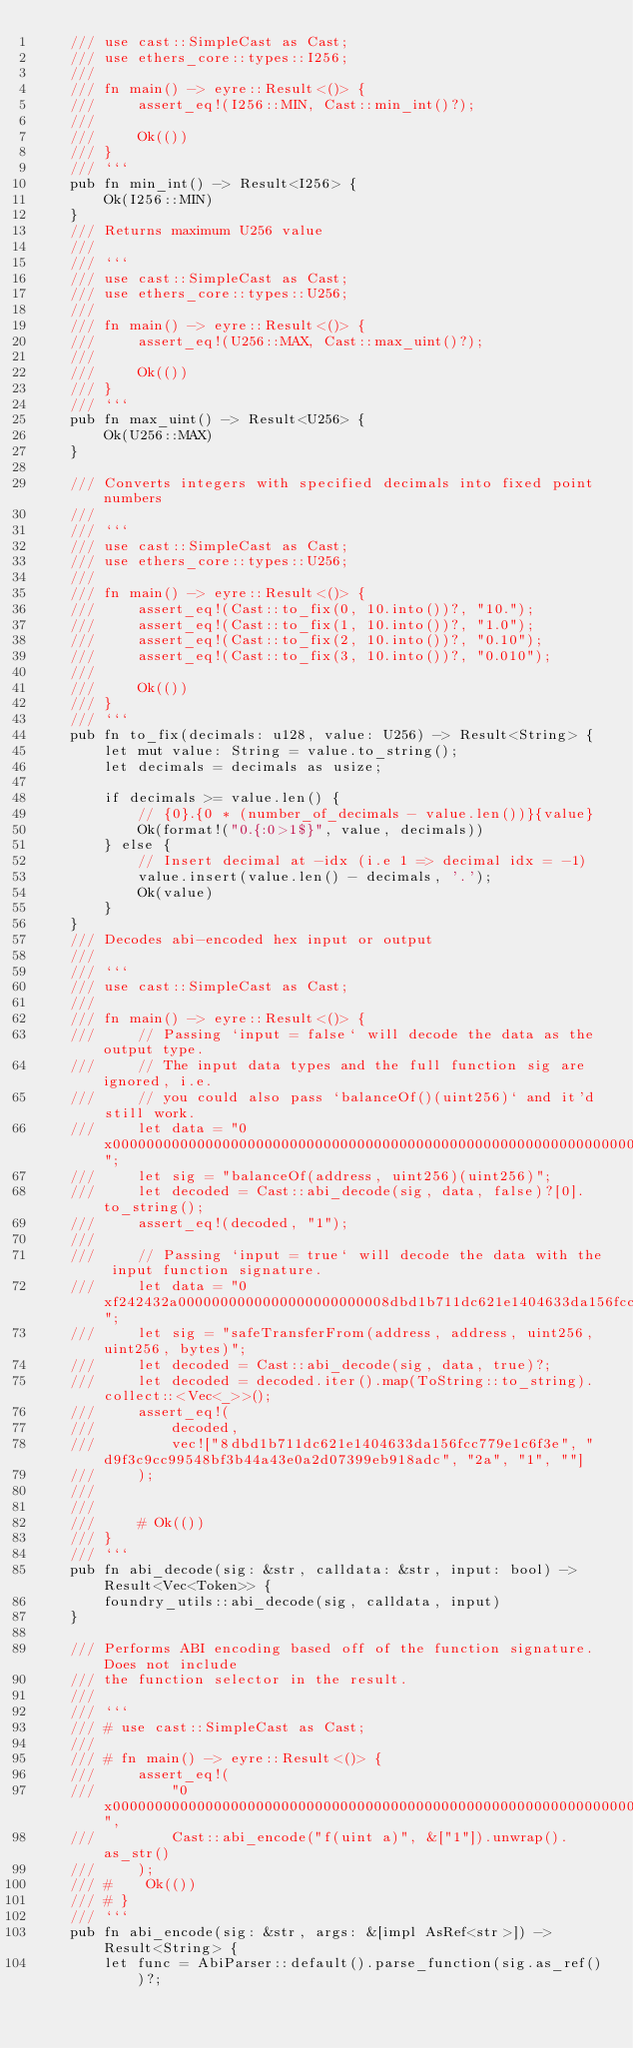Convert code to text. <code><loc_0><loc_0><loc_500><loc_500><_Rust_>    /// use cast::SimpleCast as Cast;
    /// use ethers_core::types::I256;
    ///
    /// fn main() -> eyre::Result<()> {
    ///     assert_eq!(I256::MIN, Cast::min_int()?);
    ///
    ///     Ok(())
    /// }
    /// ```
    pub fn min_int() -> Result<I256> {
        Ok(I256::MIN)
    }
    /// Returns maximum U256 value
    ///
    /// ```
    /// use cast::SimpleCast as Cast;
    /// use ethers_core::types::U256;
    ///
    /// fn main() -> eyre::Result<()> {
    ///     assert_eq!(U256::MAX, Cast::max_uint()?);
    ///
    ///     Ok(())
    /// }
    /// ```
    pub fn max_uint() -> Result<U256> {
        Ok(U256::MAX)
    }

    /// Converts integers with specified decimals into fixed point numbers
    ///
    /// ```
    /// use cast::SimpleCast as Cast;
    /// use ethers_core::types::U256;
    ///
    /// fn main() -> eyre::Result<()> {
    ///     assert_eq!(Cast::to_fix(0, 10.into())?, "10.");
    ///     assert_eq!(Cast::to_fix(1, 10.into())?, "1.0");
    ///     assert_eq!(Cast::to_fix(2, 10.into())?, "0.10");
    ///     assert_eq!(Cast::to_fix(3, 10.into())?, "0.010");
    ///
    ///     Ok(())
    /// }
    /// ```
    pub fn to_fix(decimals: u128, value: U256) -> Result<String> {
        let mut value: String = value.to_string();
        let decimals = decimals as usize;

        if decimals >= value.len() {
            // {0}.{0 * (number_of_decimals - value.len())}{value}
            Ok(format!("0.{:0>1$}", value, decimals))
        } else {
            // Insert decimal at -idx (i.e 1 => decimal idx = -1)
            value.insert(value.len() - decimals, '.');
            Ok(value)
        }
    }
    /// Decodes abi-encoded hex input or output
    ///
    /// ```
    /// use cast::SimpleCast as Cast;
    ///
    /// fn main() -> eyre::Result<()> {
    ///     // Passing `input = false` will decode the data as the output type.
    ///     // The input data types and the full function sig are ignored, i.e.
    ///     // you could also pass `balanceOf()(uint256)` and it'd still work.
    ///     let data = "0x0000000000000000000000000000000000000000000000000000000000000001";
    ///     let sig = "balanceOf(address, uint256)(uint256)";
    ///     let decoded = Cast::abi_decode(sig, data, false)?[0].to_string();
    ///     assert_eq!(decoded, "1");
    ///
    ///     // Passing `input = true` will decode the data with the input function signature.
    ///     let data = "0xf242432a0000000000000000000000008dbd1b711dc621e1404633da156fcc779e1c6f3e000000000000000000000000d9f3c9cc99548bf3b44a43e0a2d07399eb918adc000000000000000000000000000000000000000000000000000000000000002a000000000000000000000000000000000000000000000000000000000000000100000000000000000000000000000000000000000000000000000000000000a00000000000000000000000000000000000000000000000000000000000000000";
    ///     let sig = "safeTransferFrom(address, address, uint256, uint256, bytes)";
    ///     let decoded = Cast::abi_decode(sig, data, true)?;
    ///     let decoded = decoded.iter().map(ToString::to_string).collect::<Vec<_>>();
    ///     assert_eq!(
    ///         decoded,
    ///         vec!["8dbd1b711dc621e1404633da156fcc779e1c6f3e", "d9f3c9cc99548bf3b44a43e0a2d07399eb918adc", "2a", "1", ""]
    ///     );
    ///
    ///
    ///     # Ok(())
    /// }
    /// ```
    pub fn abi_decode(sig: &str, calldata: &str, input: bool) -> Result<Vec<Token>> {
        foundry_utils::abi_decode(sig, calldata, input)
    }

    /// Performs ABI encoding based off of the function signature. Does not include
    /// the function selector in the result.
    ///
    /// ```
    /// # use cast::SimpleCast as Cast;
    ///
    /// # fn main() -> eyre::Result<()> {
    ///     assert_eq!(
    ///         "0x0000000000000000000000000000000000000000000000000000000000000001",
    ///         Cast::abi_encode("f(uint a)", &["1"]).unwrap().as_str()
    ///     );
    /// #    Ok(())
    /// # }
    /// ```
    pub fn abi_encode(sig: &str, args: &[impl AsRef<str>]) -> Result<String> {
        let func = AbiParser::default().parse_function(sig.as_ref())?;</code> 